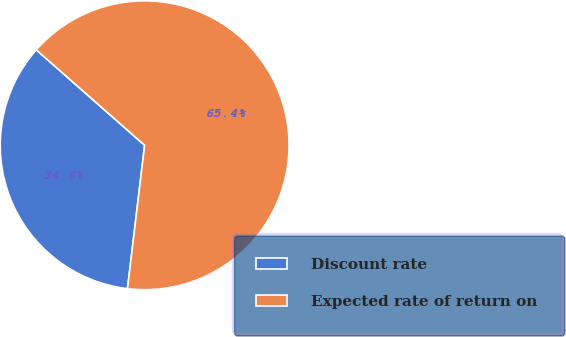Convert chart. <chart><loc_0><loc_0><loc_500><loc_500><pie_chart><fcel>Discount rate<fcel>Expected rate of return on<nl><fcel>34.6%<fcel>65.4%<nl></chart> 